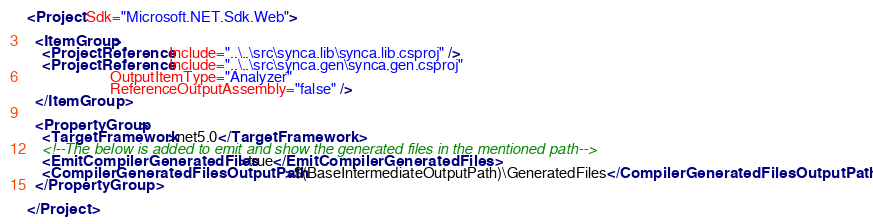<code> <loc_0><loc_0><loc_500><loc_500><_XML_><Project Sdk="Microsoft.NET.Sdk.Web">

  <ItemGroup>
    <ProjectReference Include="..\..\src\synca.lib\synca.lib.csproj" />
    <ProjectReference Include="..\..\src\synca.gen\synca.gen.csproj" 
                      OutputItemType="Analyzer"
                      ReferenceOutputAssembly="false" />
  </ItemGroup>

  <PropertyGroup>
    <TargetFramework>net5.0</TargetFramework>
    <!--The below is added to emit and show the generated files in the mentioned path-->
    <EmitCompilerGeneratedFiles>true</EmitCompilerGeneratedFiles>
    <CompilerGeneratedFilesOutputPath>$(BaseIntermediateOutputPath)\GeneratedFiles</CompilerGeneratedFilesOutputPath>
  </PropertyGroup>

</Project>
</code> 